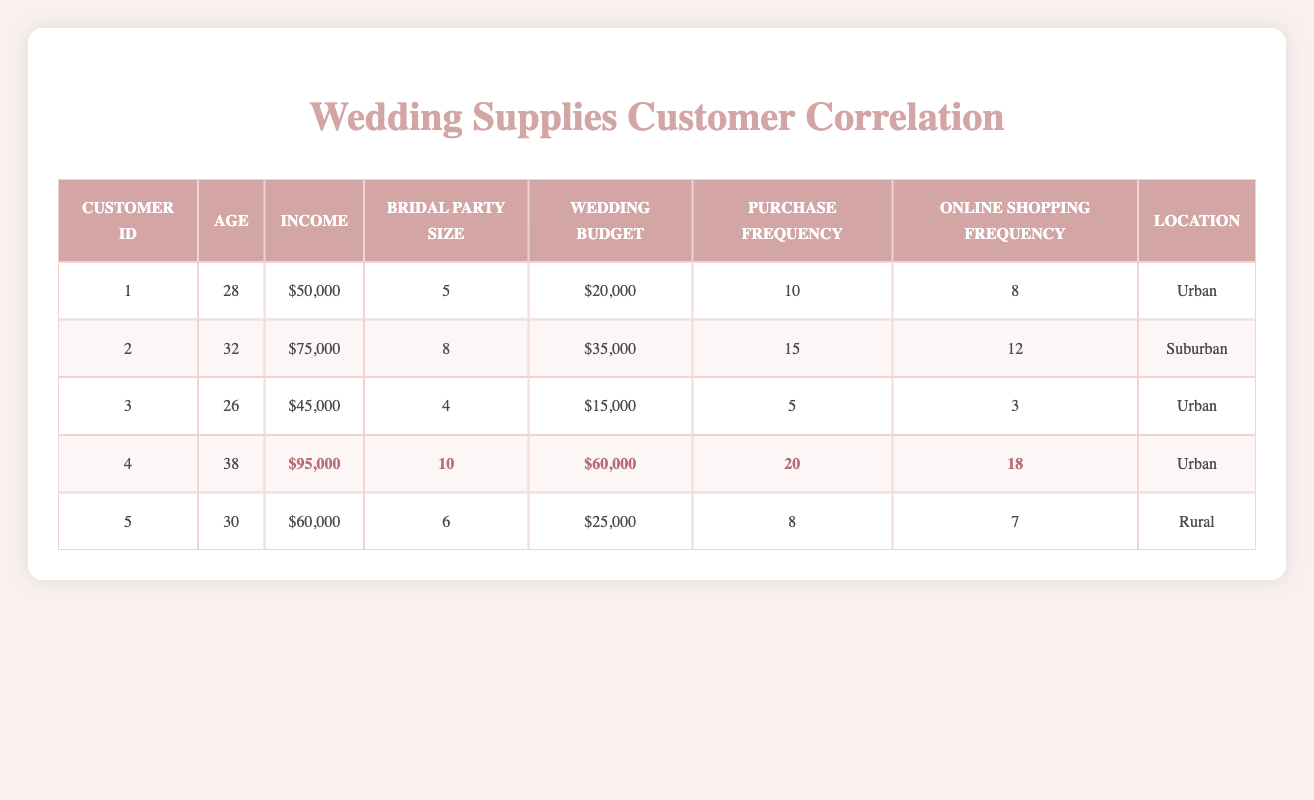What is the highest wedding budget among the customers? Looking at the "Wedding Budget" column, the highest value is $60,000, which belongs to customer ID 4.
Answer: $60,000 What is the average income of the customers? The income values are $50,000, $75,000, $45,000, $95,000, and $60,000. The sum is $325,000. There are 5 customers, so the average income is $325,000 divided by 5, which equals $65,000.
Answer: $65,000 Is customer ID 1's purchase frequency higher than that of customer ID 3? Customer ID 1 has a purchase frequency of 10, while customer ID 3 has a frequency of 5. Since 10 is greater than 5, the answer is yes.
Answer: Yes How many customers have a bridal party size greater than 6? Customers with bridal party sizes are: customer ID 1 (5), customer ID 2 (8), customer ID 3 (4), customer ID 4 (10), and customer ID 5 (6). Only customer IDs 2 and 4 have sizes greater than 6, totaling 2.
Answer: 2 What is the difference in online shopping frequency between the highest and lowest customer? The highest online shopping frequency is from customer ID 4 with 18, and the lowest is from customer ID 3 with 3. The difference is 18 minus 3, which equals 15.
Answer: 15 Which location has customers with the highest average wedding budget? The wedding budgets are: Urban group (IDs 1, 2, 4) has $20,000, $35,000, and $60,000. The Rural group (ID 5) has $25,000. Urban’s average is $38,333 (sum of urban $115,000 divided by 3) compared to Rural’s $25,000. Therefore, Urban location has the highest average wedding budget.
Answer: Urban Is it true that all customers with a bridal party size of 10 have higher wedding budgets than $50,000? Only customer ID 4 has a bridal party size of 10 and a wedding budget of $60,000, which is higher than $50,000. Therefore, the answer is true.
Answer: True 